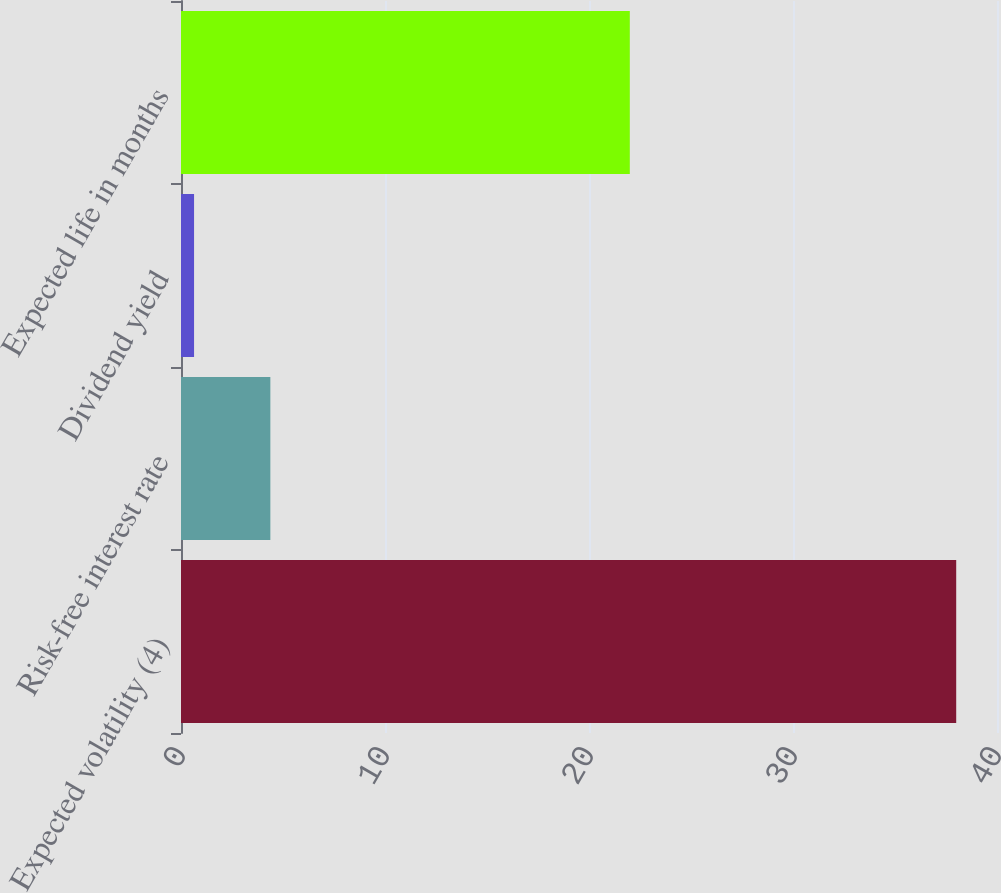<chart> <loc_0><loc_0><loc_500><loc_500><bar_chart><fcel>Expected volatility (4)<fcel>Risk-free interest rate<fcel>Dividend yield<fcel>Expected life in months<nl><fcel>38<fcel>4.38<fcel>0.64<fcel>22<nl></chart> 